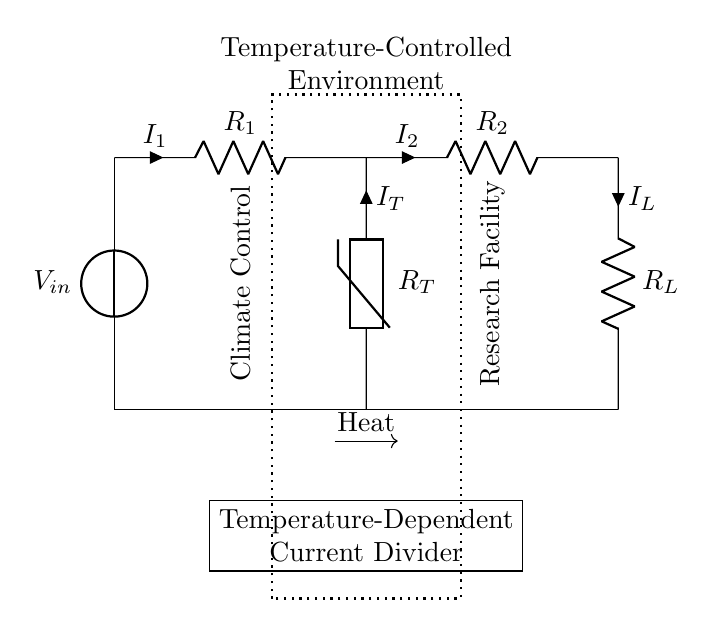What is the function of the thermistor in the circuit? The thermistor acts as a temperature-dependent resistor, changing its resistance based on the temperature, which influences current division.
Answer: Temperature-dependent resistor What is the input voltage indicated in the circuit? The input voltage is denoted as V-in, representing the source voltage applied to the circuit.
Answer: V-in How many resistors are present in the circuit? There are three resistors: R-1, R-2, and R-L, which form the current divider.
Answer: Three What is the current flowing through R-1 labeled as? The current flowing through R-1 is labeled as I-1, indicating the current's direction and magnitude through this resistor.
Answer: I-1 Which component helps regulate the current based on temperature? The component that helps regulate current based on temperature is the thermistor, as it adjusts resistance with temperature, affecting current flow.
Answer: Thermistor What does the circuit indicate about its application? The circuit is designed for a temperature-controlled environment, suggesting it is used in climate control systems for research facilities.
Answer: Climate control 